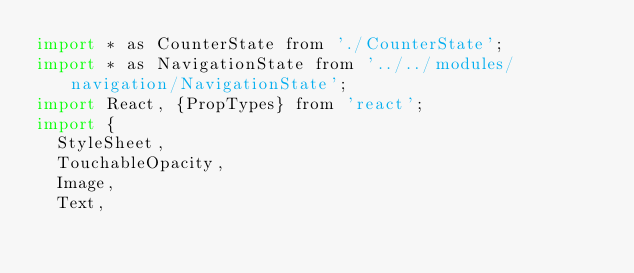<code> <loc_0><loc_0><loc_500><loc_500><_JavaScript_>import * as CounterState from './CounterState';
import * as NavigationState from '../../modules/navigation/NavigationState';
import React, {PropTypes} from 'react';
import {
  StyleSheet,
  TouchableOpacity,
  Image,
  Text,</code> 